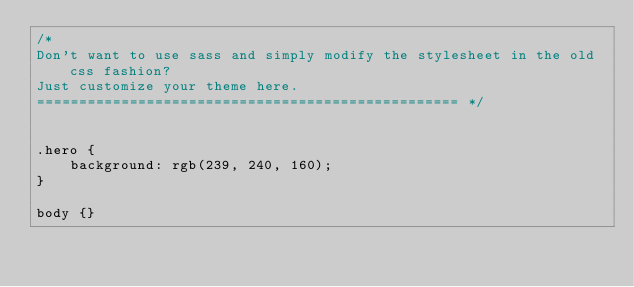<code> <loc_0><loc_0><loc_500><loc_500><_CSS_>/* 
Don't want to use sass and simply modify the stylesheet in the old css fashion? 
Just customize your theme here.
================================================== */


.hero {
    background: rgb(239, 240, 160);
}

body {}</code> 